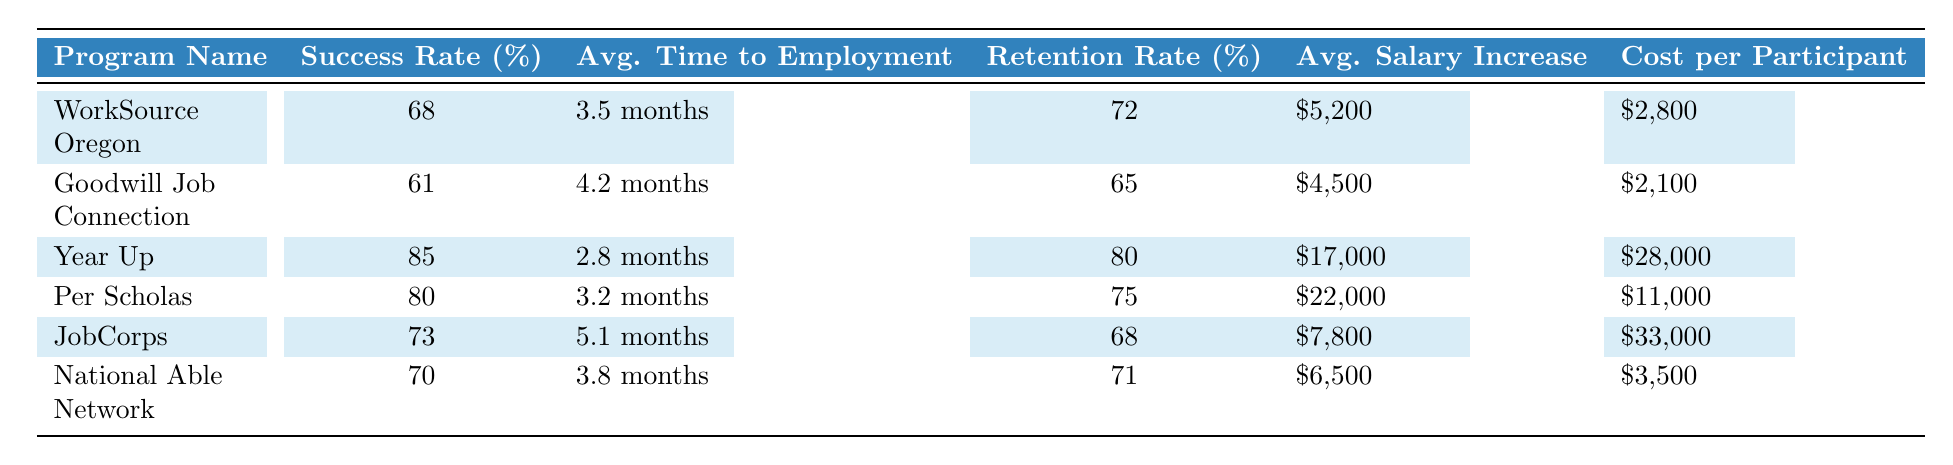What is the success rate of the Year Up program? The success rate of the Year Up program is provided in the table under the success rate column. It states that the success rate for Year Up is 85%.
Answer: 85% Which program has the lowest average time to employment? By comparing the average time to employment across all programs, the Year Up program has the lowest time at 2.8 months.
Answer: Year Up Is the retention rate after one year for Goodwill Job Connection higher than the average retention rate of all programs? First, the retention rate for Goodwill Job Connection is 65%. To find the average retention rate, we calculate the mean of 72, 65, 80, 75, 68, and 71, which equals 71. The average retention rate (71%) is higher than that of Goodwill Job Connection (65%).
Answer: No What is the total cost for a participant in the JobCorps program? The cost per participant for the JobCorps program is listed in the table as $33,000. Therefore, the total cost for one participant is simply that value.
Answer: $33,000 What is the average salary increase in programs that have a success rate higher than 70%? The programs with a success rate higher than 70% are Year Up (85%), Per Scholas (80%), and JobCorps (73%). Their average salary increases are $17,000, $22,000, and $7,800 respectively. To find the average, we sum these values (17,000 + 22,000 + 7,800 = 46,800) and divide by the number of programs (3), giving us an average of $15,600.
Answer: $15,600 Is the success rate of WorkSource Oregon higher than that of National Able Network? The success rates are 68% for WorkSource Oregon and 70% for National Able Network. Comparing these values shows that 70% is greater than 68%, thus the statement is false.
Answer: No What program has the highest average salary increase? According to the table, the average salary increase for Year Up is $17,000, which is higher than the average salary increases for all other programs.
Answer: Year Up How many programs have a retention rate of 70% or above? By reviewing the retention rates listed, they are 72%, 65%, 80%, 75%, 68%, and 71%. The programs with rates of 70% or higher are WorkSource Oregon, Year Up, Per Scholas, and National Able Network. That sums to a total of 4 programs.
Answer: 4 